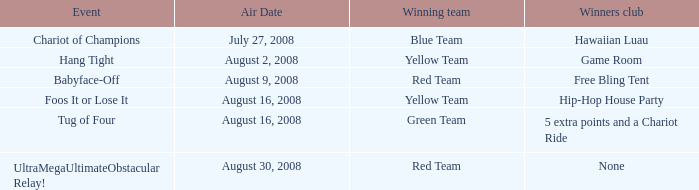For which week is the air date august 30, 2008? 5.0. Would you be able to parse every entry in this table? {'header': ['Event', 'Air Date', 'Winning team', 'Winners club'], 'rows': [['Chariot of Champions', 'July 27, 2008', 'Blue Team', 'Hawaiian Luau'], ['Hang Tight', 'August 2, 2008', 'Yellow Team', 'Game Room'], ['Babyface-Off', 'August 9, 2008', 'Red Team', 'Free Bling Tent'], ['Foos It or Lose It', 'August 16, 2008', 'Yellow Team', 'Hip-Hop House Party'], ['Tug of Four', 'August 16, 2008', 'Green Team', '5 extra points and a Chariot Ride'], ['UltraMegaUltimateObstacular Relay!', 'August 30, 2008', 'Red Team', 'None']]} 